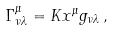<formula> <loc_0><loc_0><loc_500><loc_500>\Gamma ^ { \mu } _ { \nu \lambda } = K x ^ { \mu } g _ { \nu \lambda } \, ,</formula> 